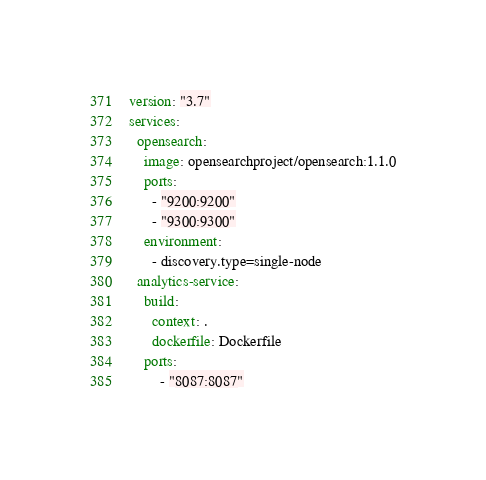Convert code to text. <code><loc_0><loc_0><loc_500><loc_500><_YAML_>version: "3.7"
services:
  opensearch:
    image: opensearchproject/opensearch:1.1.0
    ports:
      - "9200:9200"
      - "9300:9300"
    environment:
      - discovery.type=single-node
  analytics-service:
    build:
      context: .
      dockerfile: Dockerfile
    ports:
        - "8087:8087"
</code> 